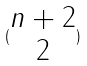Convert formula to latex. <formula><loc_0><loc_0><loc_500><loc_500>( \begin{matrix} n + 2 \\ 2 \end{matrix} )</formula> 